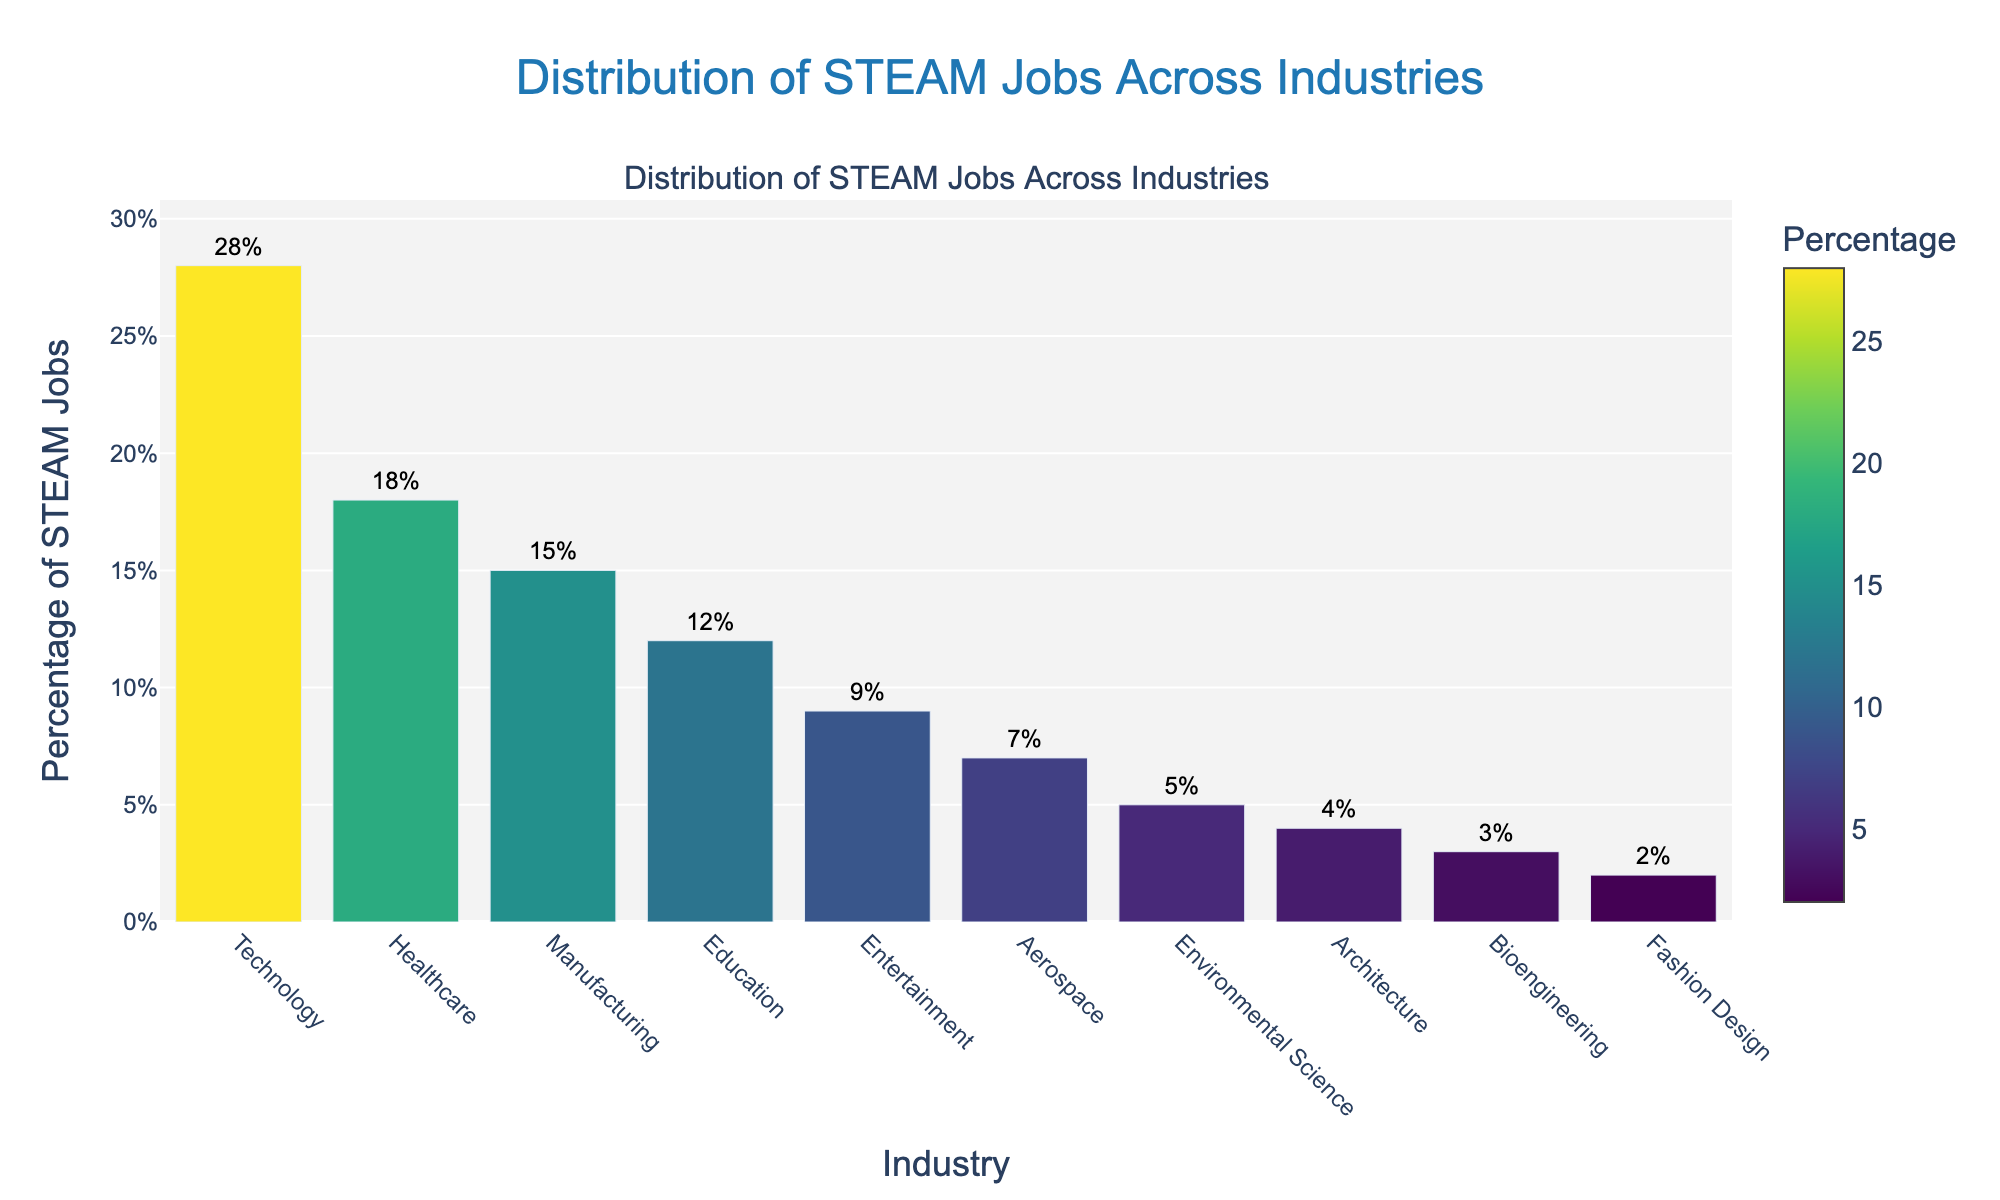Which industry has the highest percentage of STEAM jobs? The bar representing the Technology industry is the tallest, indicating the highest percentage.
Answer: Technology Which industry has the lowest percentage of STEAM jobs? The bar representing the Fashion Design industry is the shortest, indicating the lowest percentage.
Answer: Fashion Design How much higher is the percentage of STEAM jobs in Technology compared to Fashion Design? The percentage for Technology is 28%, and for Fashion Design, it's 2%. Subtracting the latter from the former: 28% - 2% = 26%.
Answer: 26% What is the total percentage of STEAM jobs in Healthcare, Aerospace, and Environmental Science combined? Sum the percentages: Healthcare (18%) + Aerospace (7%) + Environmental Science (5%) = 30%.
Answer: 30% Between Manufacturing and Education, which industry has a bigger share of STEAM jobs and by how much? Manufacturing has 15%, and Education has 12%. Subtract the latter from the former: 15% - 12% = 3%.
Answer: Manufacturing, 3% What percentage of STEAM jobs is in non-technical fields (Entertainment, Architecture, Fashion Design)? Sum the respective percentages: Entertainment (9%) + Architecture (4%) + Fashion Design (2%) = 15%.
Answer: 15% Which industry shows a middle-range percentage of STEAM jobs, considering all industries shown? Manufacturing shows a middle-range percentage at 15%, sitting between the highest and the lowest percentages.
Answer: Manufacturing How does the percentage of STEAM jobs in Environmental Science compare visually to that in Aerospace? The bar for Environmental Science is shorter compared to the bar for Aerospace, indicating fewer STEAM jobs.
Answer: Environmental Science has fewer What is the difference in percentage points between the Technology and Entertainment industries? Technology is at 28%, and Entertainment is at 9%. Subtract the latter from the former: 28% - 9% = 19%.
Answer: 19% Which industries have a percentage of STEAM jobs higher than 10% but less than 20%? Healthcare (18%), Manufacturing (15%), and Education (12%) all fall within this range.
Answer: Healthcare, Manufacturing, Education 